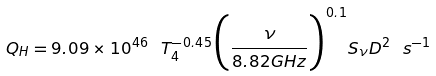Convert formula to latex. <formula><loc_0><loc_0><loc_500><loc_500>Q _ { H } = 9 . 0 9 \times 1 0 ^ { 4 6 } \ T _ { 4 } ^ { - 0 . 4 5 } \Big { ( } \frac { \nu } { 8 . 8 2 G H z } \Big { ) } ^ { 0 . 1 } S _ { \nu } D ^ { 2 } \ s ^ { - 1 }</formula> 